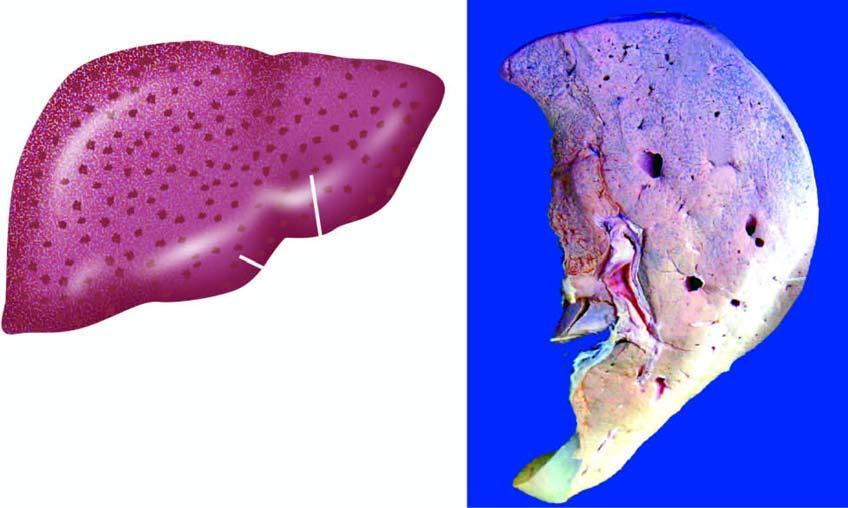does the cut surface show mottled appearance-alternate pattern of dark congestion and pale fatty change?
Answer the question using a single word or phrase. Yes 